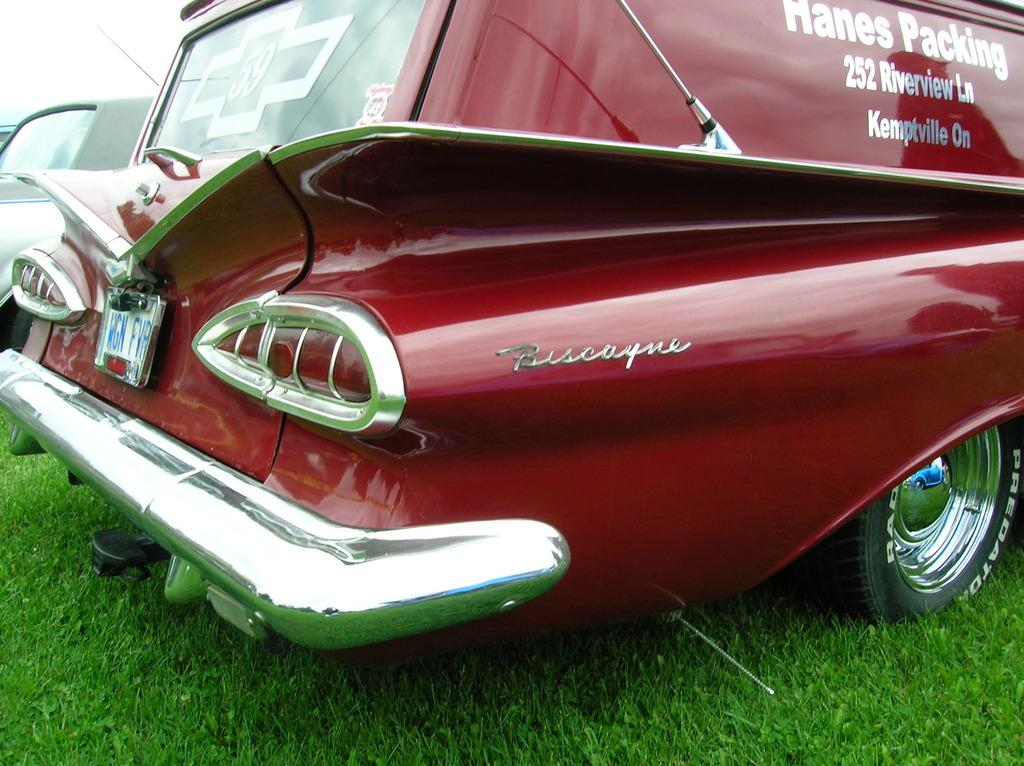What type of vehicles can be seen in the image? There are cars in the image. What type of vegetation is visible at the bottom of the image? There is grass at the bottom of the image. What type of bell can be heard ringing in the image? There is no bell present in the image, and therefore no sound can be heard. 